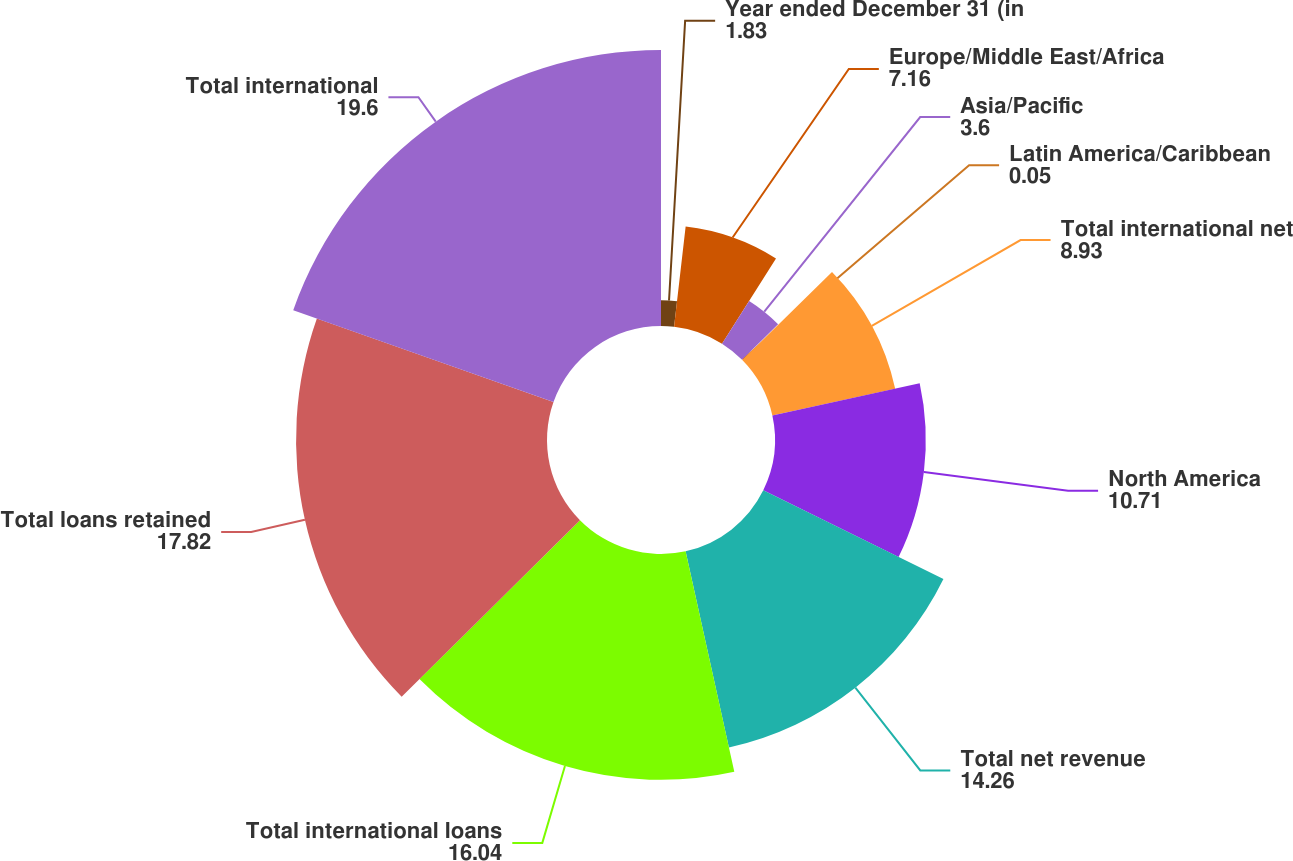<chart> <loc_0><loc_0><loc_500><loc_500><pie_chart><fcel>Year ended December 31 (in<fcel>Europe/Middle East/Africa<fcel>Asia/Pacific<fcel>Latin America/Caribbean<fcel>Total international net<fcel>North America<fcel>Total net revenue<fcel>Total international loans<fcel>Total loans retained<fcel>Total international<nl><fcel>1.83%<fcel>7.16%<fcel>3.6%<fcel>0.05%<fcel>8.93%<fcel>10.71%<fcel>14.26%<fcel>16.04%<fcel>17.82%<fcel>19.6%<nl></chart> 